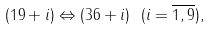<formula> <loc_0><loc_0><loc_500><loc_500>( 1 9 + i ) \Leftrightarrow ( 3 6 + i ) \ ( i = \overline { 1 , 9 } ) ,</formula> 